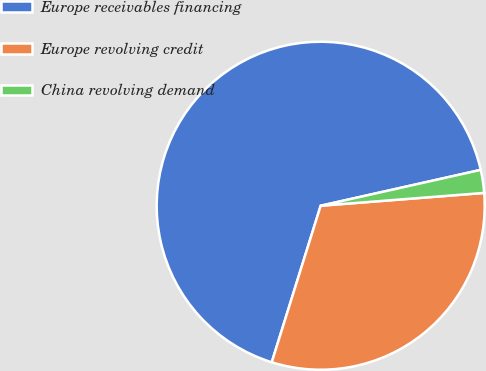Convert chart. <chart><loc_0><loc_0><loc_500><loc_500><pie_chart><fcel>Europe receivables financing<fcel>Europe revolving credit<fcel>China revolving demand<nl><fcel>66.67%<fcel>31.07%<fcel>2.26%<nl></chart> 